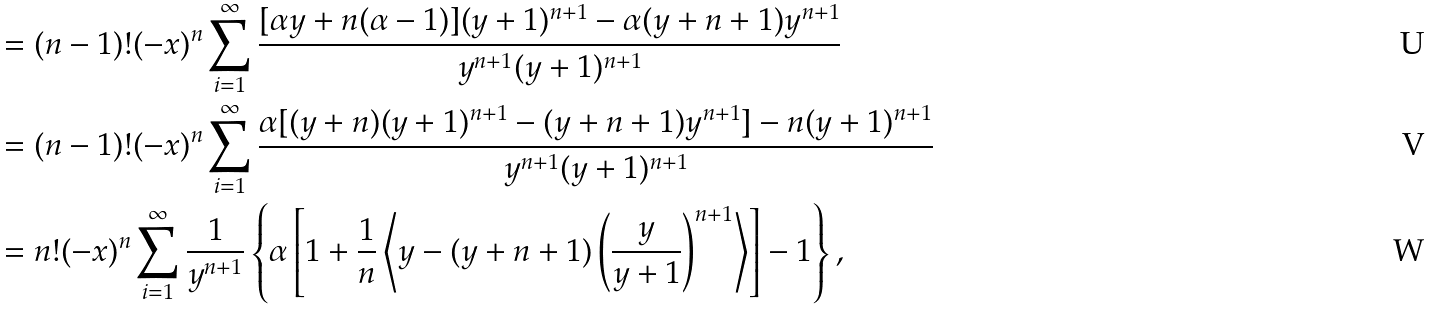Convert formula to latex. <formula><loc_0><loc_0><loc_500><loc_500>& = ( n - 1 ) ! ( - x ) ^ { n } \sum _ { i = 1 } ^ { \infty } \frac { [ \alpha y + n ( \alpha - 1 ) ] ( y + 1 ) ^ { n + 1 } - \alpha ( y + n + 1 ) y ^ { n + 1 } } { y ^ { n + 1 } ( y + 1 ) ^ { n + 1 } } \\ & = ( n - 1 ) ! ( - x ) ^ { n } \sum _ { i = 1 } ^ { \infty } \frac { \alpha [ ( y + n ) ( y + 1 ) ^ { n + 1 } - ( y + n + 1 ) y ^ { n + 1 } ] - n ( y + 1 ) ^ { n + 1 } } { y ^ { n + 1 } ( y + 1 ) ^ { n + 1 } } \\ & = n ! ( - x ) ^ { n } \sum _ { i = 1 } ^ { \infty } \frac { 1 } { y ^ { n + 1 } } \left \{ \alpha \left [ 1 + \frac { 1 } { n } \left \langle y - ( y + n + 1 ) \left ( \frac { y } { y + 1 } \right ) ^ { n + 1 } \right \rangle \right ] - 1 \right \} ,</formula> 